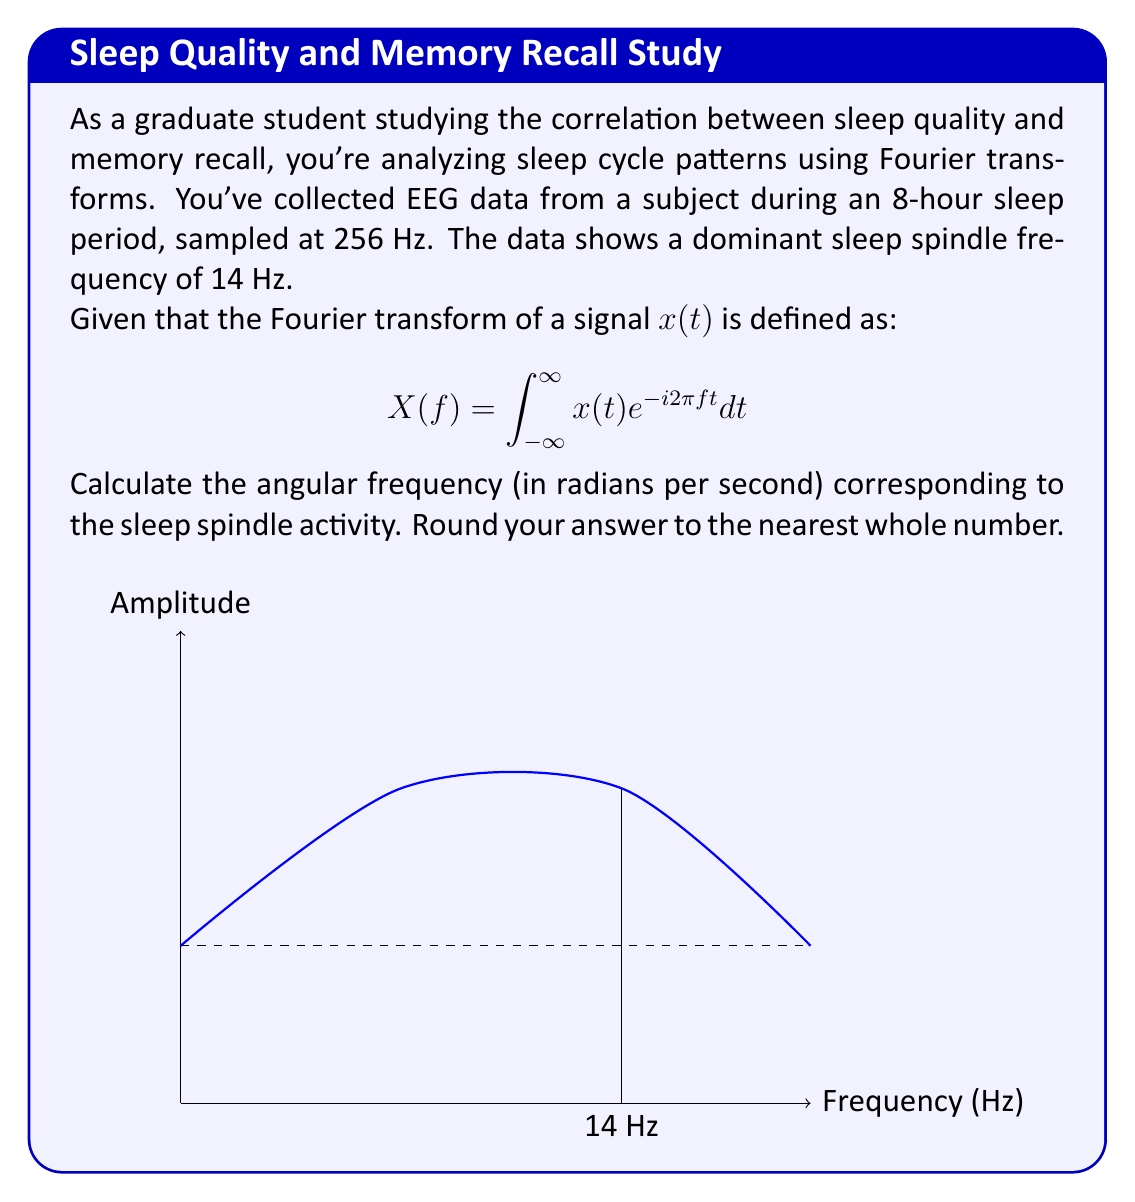Teach me how to tackle this problem. Let's approach this step-by-step:

1) First, recall that angular frequency $\omega$ is related to frequency $f$ by the equation:

   $$\omega = 2\pi f$$

2) We're given that the dominant sleep spindle frequency is 14 Hz. This is our $f$.

3) Let's substitute this into our equation:

   $$\omega = 2\pi (14)$$

4) Now, let's calculate:

   $$\omega = 2 * 3.14159... * 14 = 87.9646...$$

5) Rounding to the nearest whole number:

   $$\omega \approx 88$$

Therefore, the angular frequency corresponding to the sleep spindle activity is approximately 88 radians per second.
Answer: 88 rad/s 